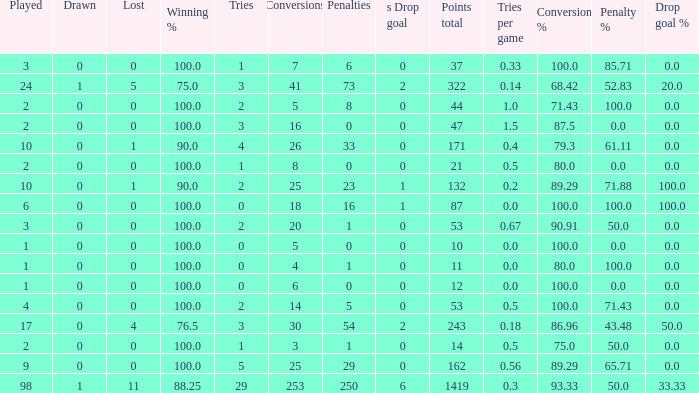What is the least number of penalties he got when his point total was over 1419 in more than 98 games? None. 